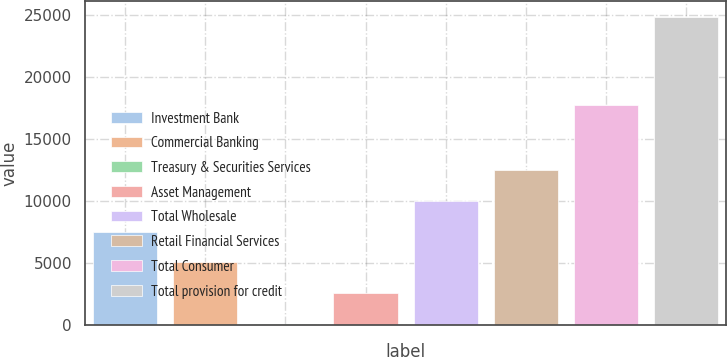Convert chart to OTSL. <chart><loc_0><loc_0><loc_500><loc_500><bar_chart><fcel>Investment Bank<fcel>Commercial Banking<fcel>Treasury & Securities Services<fcel>Asset Management<fcel>Total Wholesale<fcel>Retail Financial Services<fcel>Total Consumer<fcel>Total provision for credit<nl><fcel>7491.1<fcel>5011.4<fcel>52<fcel>2531.7<fcel>9970.8<fcel>12450.5<fcel>17701<fcel>24849<nl></chart> 